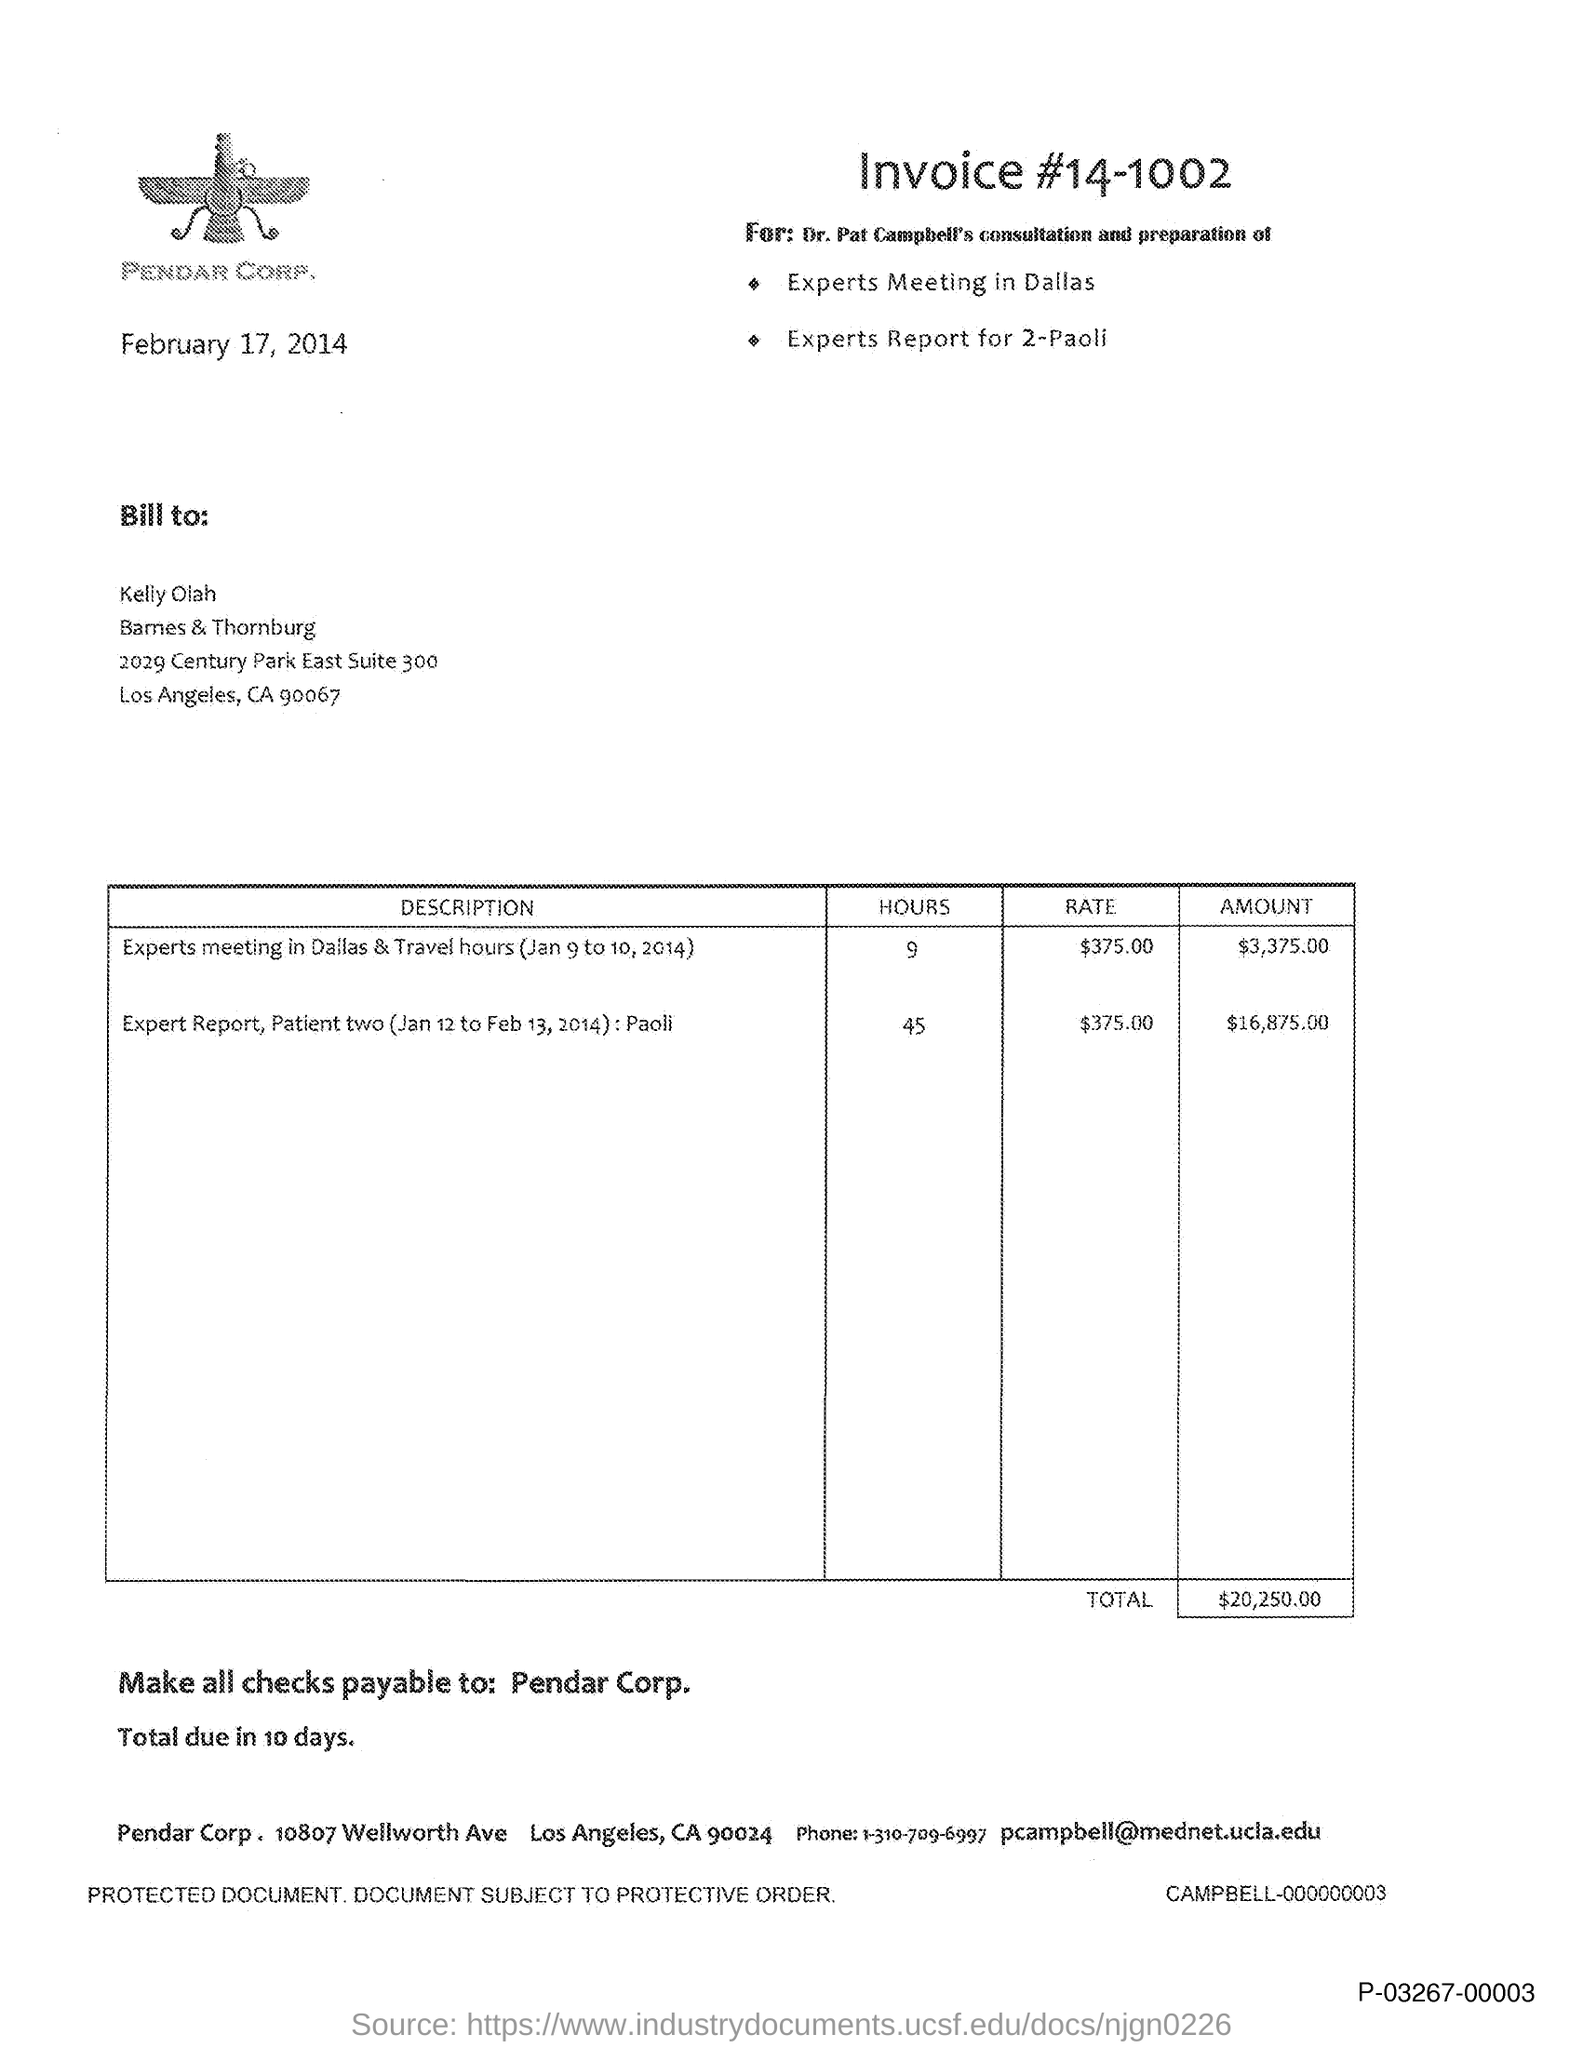Highlight a few significant elements in this photo. The invoice number mentioned in the document is 14-1002. The issued date of the invoice is February 17, 2014. The email address of Pendar Corp. is [pcampbell@mednet.ucla.edu](mailto:pcampbell@mednet.ucla.edu). The checks are payable to Pendar Corp. 